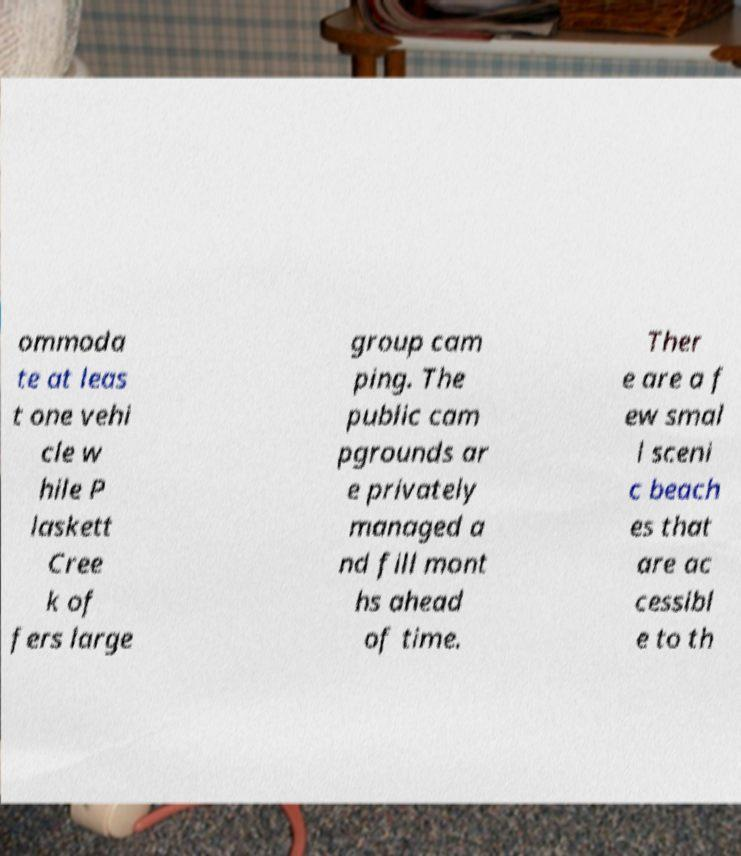Please read and relay the text visible in this image. What does it say? ommoda te at leas t one vehi cle w hile P laskett Cree k of fers large group cam ping. The public cam pgrounds ar e privately managed a nd fill mont hs ahead of time. Ther e are a f ew smal l sceni c beach es that are ac cessibl e to th 